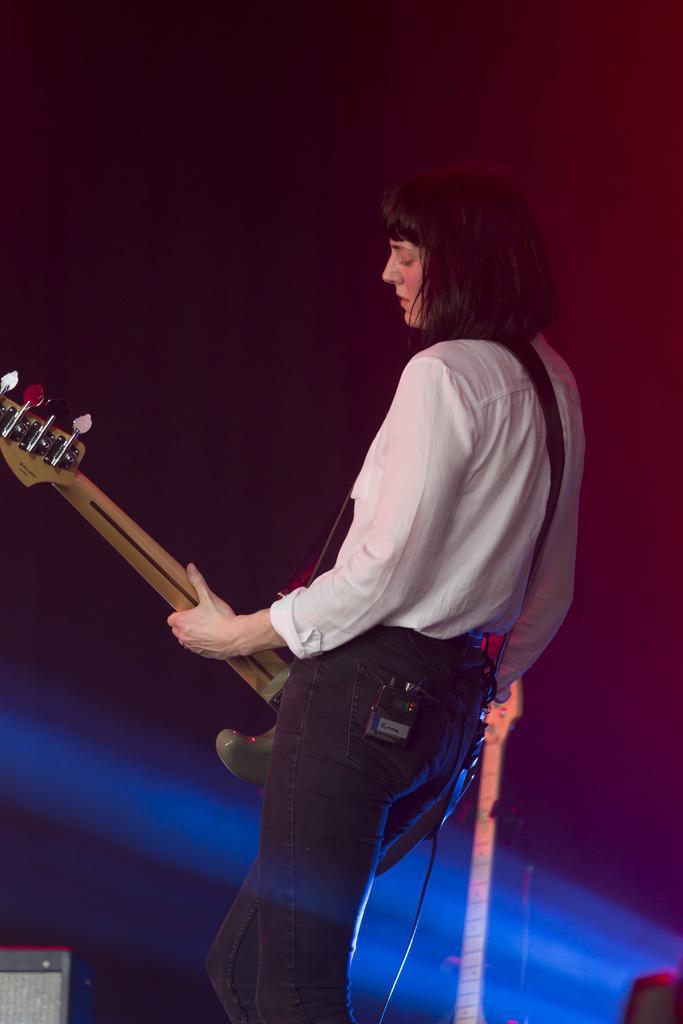Could you give a brief overview of what you see in this image? There is one lady wearing a white color shirt and holding a guitar in the middle of this image. It is dark in the background. 